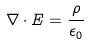<formula> <loc_0><loc_0><loc_500><loc_500>\nabla \cdot E = \frac { \rho } { \epsilon _ { 0 } }</formula> 